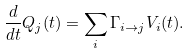<formula> <loc_0><loc_0><loc_500><loc_500>\frac { d } { d t } Q _ { j } ( t ) = \sum _ { i } \Gamma _ { i \rightarrow j } V _ { i } ( t ) .</formula> 